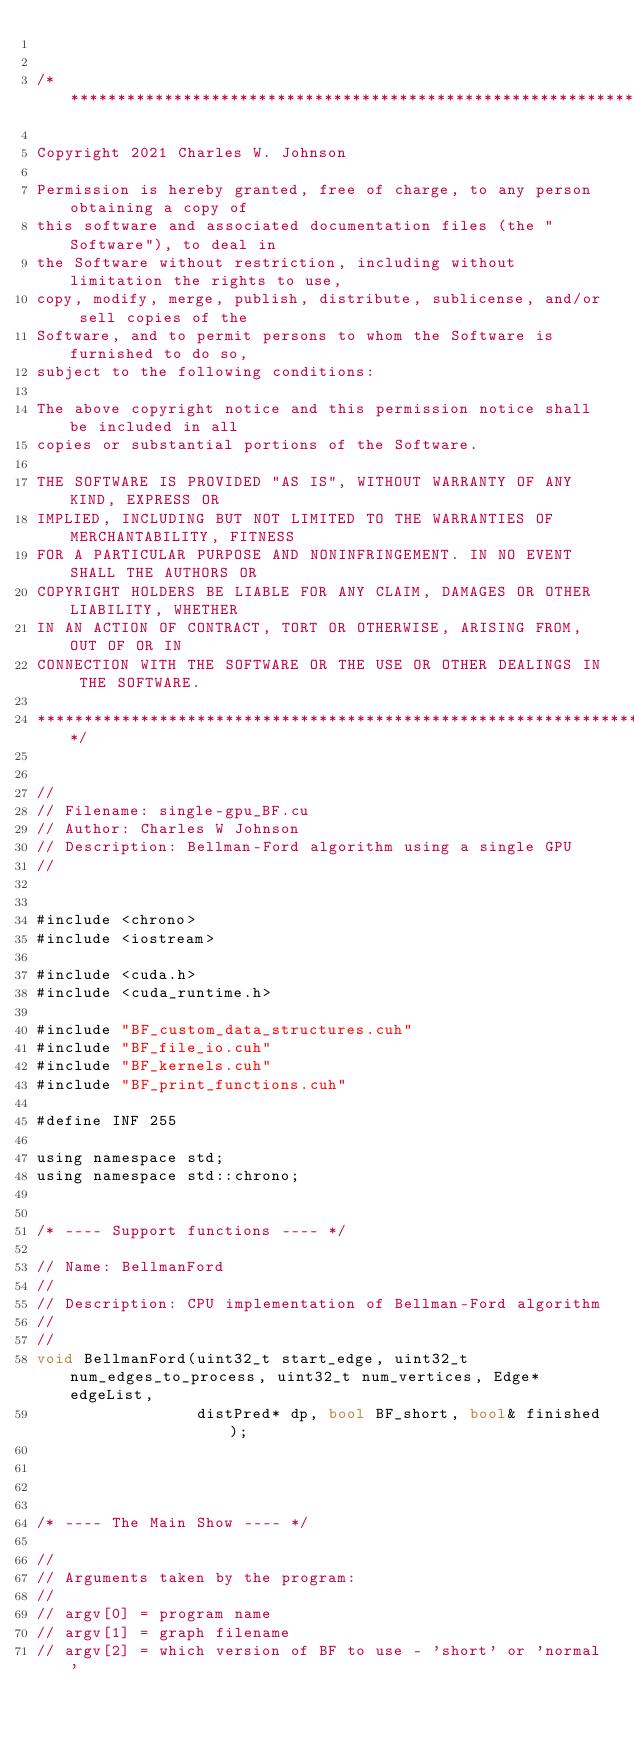<code> <loc_0><loc_0><loc_500><loc_500><_Cuda_>

/**********************************************************************************

Copyright 2021 Charles W. Johnson
 
Permission is hereby granted, free of charge, to any person obtaining a copy of
this software and associated documentation files (the "Software"), to deal in
the Software without restriction, including without limitation the rights to use,
copy, modify, merge, publish, distribute, sublicense, and/or sell copies of the
Software, and to permit persons to whom the Software is furnished to do so,
subject to the following conditions:
  
The above copyright notice and this permission notice shall be included in all
copies or substantial portions of the Software.
 
THE SOFTWARE IS PROVIDED "AS IS", WITHOUT WARRANTY OF ANY KIND, EXPRESS OR
IMPLIED, INCLUDING BUT NOT LIMITED TO THE WARRANTIES OF MERCHANTABILITY, FITNESS
FOR A PARTICULAR PURPOSE AND NONINFRINGEMENT. IN NO EVENT SHALL THE AUTHORS OR
COPYRIGHT HOLDERS BE LIABLE FOR ANY CLAIM, DAMAGES OR OTHER LIABILITY, WHETHER
IN AN ACTION OF CONTRACT, TORT OR OTHERWISE, ARISING FROM, OUT OF OR IN
CONNECTION WITH THE SOFTWARE OR THE USE OR OTHER DEALINGS IN THE SOFTWARE.
 
**********************************************************************************/


//
// Filename: single-gpu_BF.cu
// Author: Charles W Johnson
// Description: Bellman-Ford algorithm using a single GPU
//


#include <chrono>
#include <iostream>

#include <cuda.h>
#include <cuda_runtime.h>

#include "BF_custom_data_structures.cuh"
#include "BF_file_io.cuh"
#include "BF_kernels.cuh"
#include "BF_print_functions.cuh"

#define INF 255

using namespace std;
using namespace std::chrono;


/* ---- Support functions ---- */

// Name: BellmanFord
//
// Description: CPU implementation of Bellman-Ford algorithm
//
//
void BellmanFord(uint32_t start_edge, uint32_t num_edges_to_process, uint32_t num_vertices, Edge* edgeList, 
                 distPred* dp, bool BF_short, bool& finished);




/* ---- The Main Show ---- */

//
// Arguments taken by the program:
//
// argv[0] = program name
// argv[1] = graph filename
// argv[2] = which version of BF to use - 'short' or 'normal'</code> 